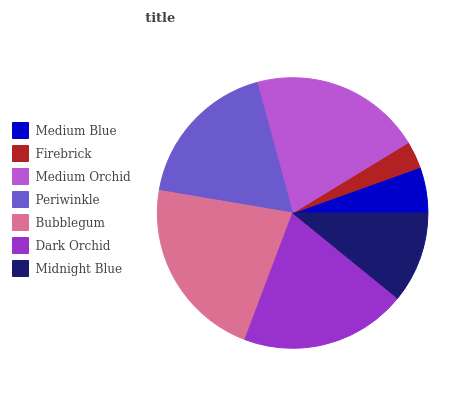Is Firebrick the minimum?
Answer yes or no. Yes. Is Bubblegum the maximum?
Answer yes or no. Yes. Is Medium Orchid the minimum?
Answer yes or no. No. Is Medium Orchid the maximum?
Answer yes or no. No. Is Medium Orchid greater than Firebrick?
Answer yes or no. Yes. Is Firebrick less than Medium Orchid?
Answer yes or no. Yes. Is Firebrick greater than Medium Orchid?
Answer yes or no. No. Is Medium Orchid less than Firebrick?
Answer yes or no. No. Is Periwinkle the high median?
Answer yes or no. Yes. Is Periwinkle the low median?
Answer yes or no. Yes. Is Medium Orchid the high median?
Answer yes or no. No. Is Medium Blue the low median?
Answer yes or no. No. 